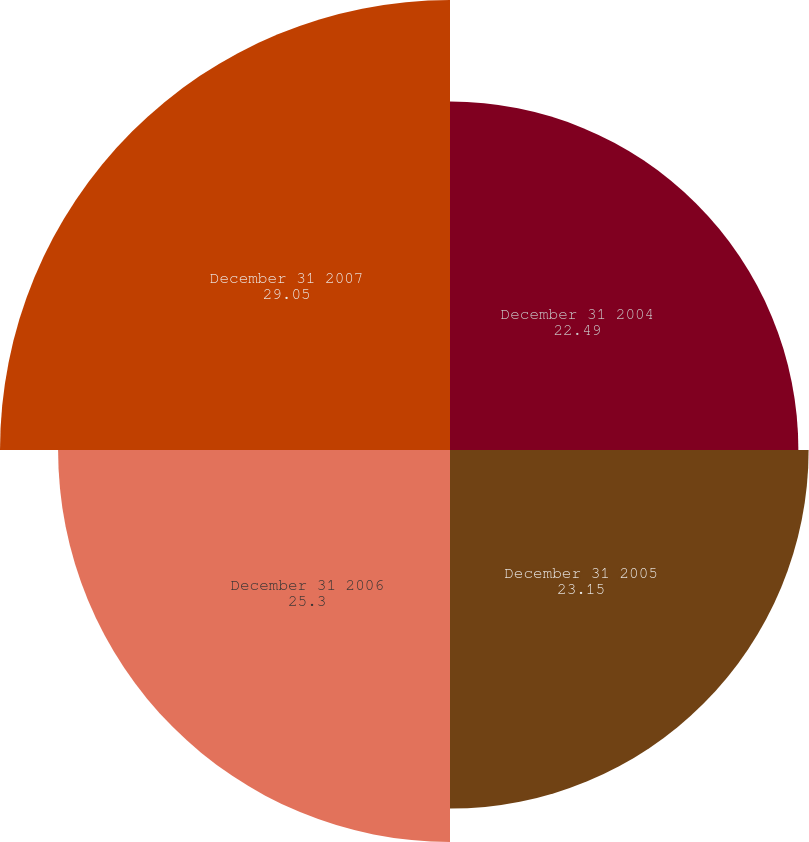Convert chart to OTSL. <chart><loc_0><loc_0><loc_500><loc_500><pie_chart><fcel>December 31 2004<fcel>December 31 2005<fcel>December 31 2006<fcel>December 31 2007<nl><fcel>22.49%<fcel>23.15%<fcel>25.3%<fcel>29.05%<nl></chart> 